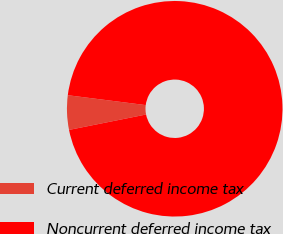<chart> <loc_0><loc_0><loc_500><loc_500><pie_chart><fcel>Current deferred income tax<fcel>Noncurrent deferred income tax<nl><fcel>5.15%<fcel>94.85%<nl></chart> 